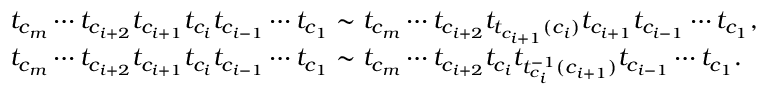Convert formula to latex. <formula><loc_0><loc_0><loc_500><loc_500>\begin{array} { r l } & { t _ { c _ { m } } \cdots t _ { c _ { i + 2 } } t _ { c _ { i + 1 } } t _ { c _ { i } } t _ { c _ { i - 1 } } \cdots t _ { c _ { 1 } } \sim t _ { c _ { m } } \cdots t _ { c _ { i + 2 } } t _ { t _ { c _ { i + 1 } } ( c _ { i } ) } t _ { c _ { i + 1 } } t _ { c _ { i - 1 } } \cdots t _ { c _ { 1 } } , } \\ & { t _ { c _ { m } } \cdots t _ { c _ { i + 2 } } t _ { c _ { i + 1 } } t _ { c _ { i } } t _ { c _ { i - 1 } } \cdots t _ { c _ { 1 } } \sim t _ { c _ { m } } \cdots t _ { c _ { i + 2 } } t _ { c _ { i } } t _ { t _ { c _ { i } } ^ { - 1 } ( c _ { i + 1 } ) } t _ { c _ { i - 1 } } \cdots t _ { c _ { 1 } } . } \end{array}</formula> 